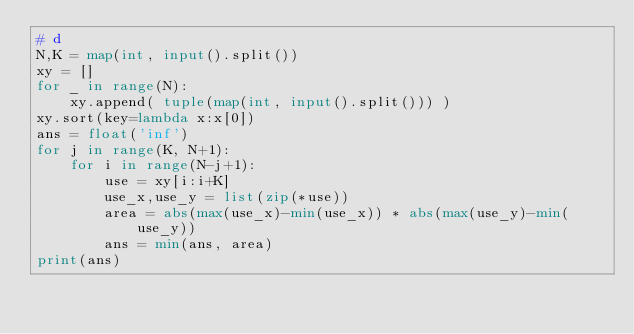<code> <loc_0><loc_0><loc_500><loc_500><_Python_># d
N,K = map(int, input().split())
xy = []
for _ in range(N):
    xy.append( tuple(map(int, input().split())) )
xy.sort(key=lambda x:x[0])
ans = float('inf')
for j in range(K, N+1):
    for i in range(N-j+1):
        use = xy[i:i+K]
        use_x,use_y = list(zip(*use))
        area = abs(max(use_x)-min(use_x)) * abs(max(use_y)-min(use_y))
        ans = min(ans, area)
print(ans)</code> 